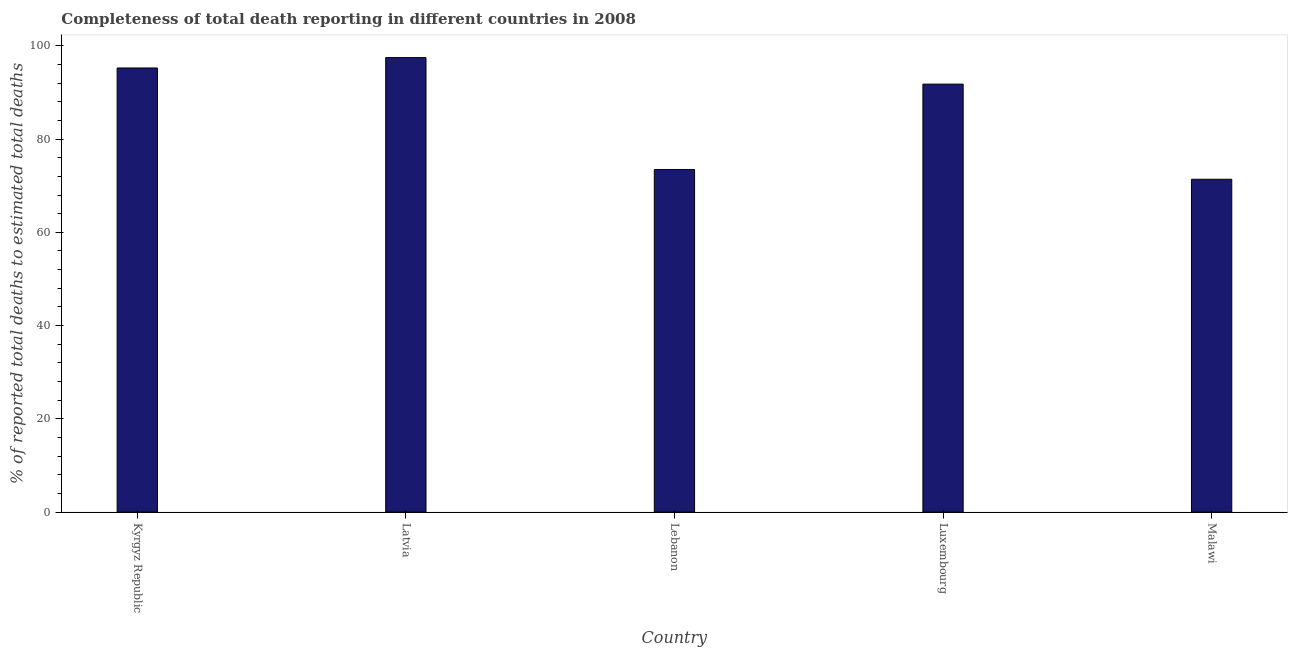Does the graph contain any zero values?
Your answer should be very brief. No. Does the graph contain grids?
Make the answer very short. No. What is the title of the graph?
Your answer should be compact. Completeness of total death reporting in different countries in 2008. What is the label or title of the Y-axis?
Offer a terse response. % of reported total deaths to estimated total deaths. What is the completeness of total death reports in Luxembourg?
Provide a succinct answer. 91.8. Across all countries, what is the maximum completeness of total death reports?
Your response must be concise. 97.49. Across all countries, what is the minimum completeness of total death reports?
Offer a very short reply. 71.39. In which country was the completeness of total death reports maximum?
Ensure brevity in your answer.  Latvia. In which country was the completeness of total death reports minimum?
Your response must be concise. Malawi. What is the sum of the completeness of total death reports?
Your answer should be compact. 429.44. What is the difference between the completeness of total death reports in Latvia and Luxembourg?
Provide a short and direct response. 5.69. What is the average completeness of total death reports per country?
Make the answer very short. 85.89. What is the median completeness of total death reports?
Ensure brevity in your answer.  91.8. In how many countries, is the completeness of total death reports greater than 96 %?
Offer a very short reply. 1. Is the difference between the completeness of total death reports in Kyrgyz Republic and Luxembourg greater than the difference between any two countries?
Make the answer very short. No. What is the difference between the highest and the second highest completeness of total death reports?
Your answer should be compact. 2.23. What is the difference between the highest and the lowest completeness of total death reports?
Provide a succinct answer. 26.1. How many bars are there?
Give a very brief answer. 5. How many countries are there in the graph?
Your response must be concise. 5. Are the values on the major ticks of Y-axis written in scientific E-notation?
Provide a short and direct response. No. What is the % of reported total deaths to estimated total deaths in Kyrgyz Republic?
Offer a very short reply. 95.26. What is the % of reported total deaths to estimated total deaths of Latvia?
Offer a terse response. 97.49. What is the % of reported total deaths to estimated total deaths of Lebanon?
Offer a very short reply. 73.49. What is the % of reported total deaths to estimated total deaths in Luxembourg?
Your answer should be very brief. 91.8. What is the % of reported total deaths to estimated total deaths of Malawi?
Ensure brevity in your answer.  71.39. What is the difference between the % of reported total deaths to estimated total deaths in Kyrgyz Republic and Latvia?
Provide a short and direct response. -2.23. What is the difference between the % of reported total deaths to estimated total deaths in Kyrgyz Republic and Lebanon?
Your answer should be compact. 21.77. What is the difference between the % of reported total deaths to estimated total deaths in Kyrgyz Republic and Luxembourg?
Provide a succinct answer. 3.46. What is the difference between the % of reported total deaths to estimated total deaths in Kyrgyz Republic and Malawi?
Provide a short and direct response. 23.87. What is the difference between the % of reported total deaths to estimated total deaths in Latvia and Lebanon?
Your answer should be very brief. 24. What is the difference between the % of reported total deaths to estimated total deaths in Latvia and Luxembourg?
Your answer should be very brief. 5.69. What is the difference between the % of reported total deaths to estimated total deaths in Latvia and Malawi?
Your answer should be compact. 26.1. What is the difference between the % of reported total deaths to estimated total deaths in Lebanon and Luxembourg?
Give a very brief answer. -18.31. What is the difference between the % of reported total deaths to estimated total deaths in Lebanon and Malawi?
Your response must be concise. 2.1. What is the difference between the % of reported total deaths to estimated total deaths in Luxembourg and Malawi?
Provide a short and direct response. 20.41. What is the ratio of the % of reported total deaths to estimated total deaths in Kyrgyz Republic to that in Latvia?
Your answer should be very brief. 0.98. What is the ratio of the % of reported total deaths to estimated total deaths in Kyrgyz Republic to that in Lebanon?
Your response must be concise. 1.3. What is the ratio of the % of reported total deaths to estimated total deaths in Kyrgyz Republic to that in Luxembourg?
Make the answer very short. 1.04. What is the ratio of the % of reported total deaths to estimated total deaths in Kyrgyz Republic to that in Malawi?
Provide a short and direct response. 1.33. What is the ratio of the % of reported total deaths to estimated total deaths in Latvia to that in Lebanon?
Keep it short and to the point. 1.33. What is the ratio of the % of reported total deaths to estimated total deaths in Latvia to that in Luxembourg?
Your answer should be compact. 1.06. What is the ratio of the % of reported total deaths to estimated total deaths in Latvia to that in Malawi?
Your response must be concise. 1.37. What is the ratio of the % of reported total deaths to estimated total deaths in Lebanon to that in Luxembourg?
Keep it short and to the point. 0.8. What is the ratio of the % of reported total deaths to estimated total deaths in Luxembourg to that in Malawi?
Your answer should be compact. 1.29. 